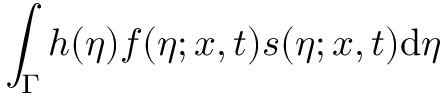<formula> <loc_0><loc_0><loc_500><loc_500>\int _ { \Gamma } h ( \eta ) f ( \eta ; x , t ) s ( \eta ; x , t ) d \eta</formula> 